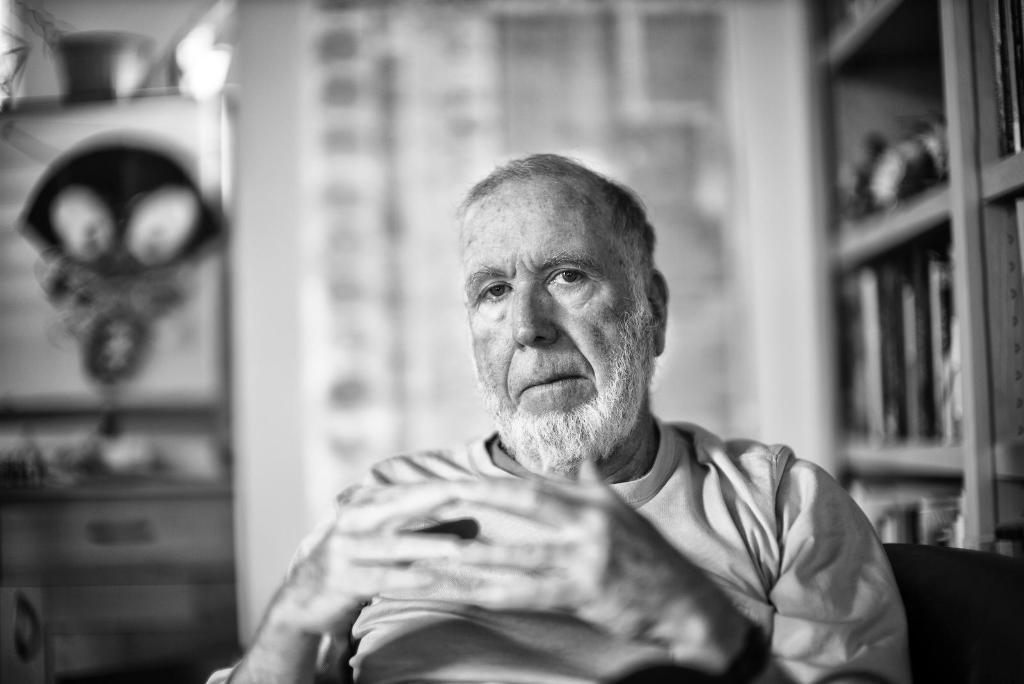In one or two sentences, can you explain what this image depicts? This is a black and white picture. Background portion of the picture is blur. In this picture we can see an old man. On the right side of the picture we can see few objects in the racks. 